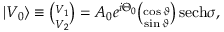Convert formula to latex. <formula><loc_0><loc_0><loc_500><loc_500>\begin{array} { r } { | V _ { 0 } \rangle \equiv \binom { V _ { 1 } } { V _ { 2 } } = A _ { 0 } e ^ { i \Theta _ { 0 } } \binom { \cos \vartheta } { \sin \vartheta } \, s e c h \sigma , } \end{array}</formula> 